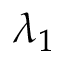<formula> <loc_0><loc_0><loc_500><loc_500>\lambda _ { 1 }</formula> 